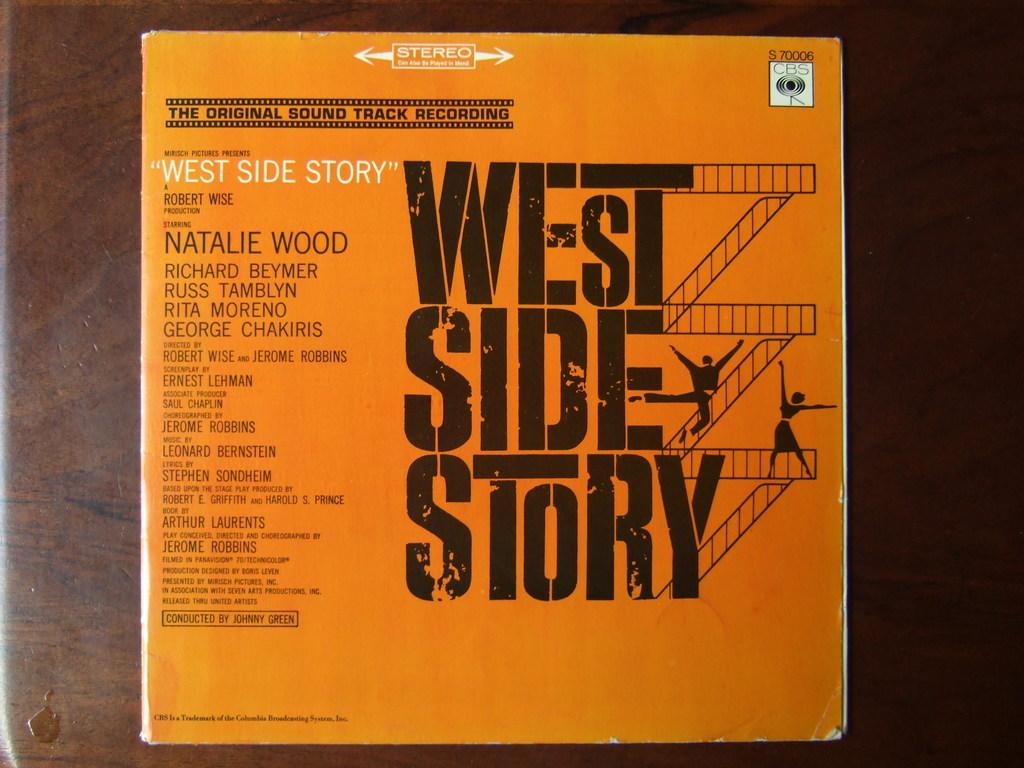What is the main object in the image? There is a board in the image. What color is the board? The board is orange in color. How is the board positioned in the image? The board is attached to some surface. How many eyes can be seen on the board in the image? There are no eyes present on the board in the image. 